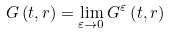<formula> <loc_0><loc_0><loc_500><loc_500>G \left ( t , r \right ) = \lim _ { \varepsilon \rightarrow 0 } G ^ { \varepsilon } \left ( t , r \right )</formula> 